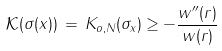<formula> <loc_0><loc_0><loc_500><loc_500>\mathcal { K } ( \sigma ( x ) ) \, = \, K _ { o , N } ( \sigma _ { x } ) \geq - \frac { w ^ { \prime \prime } ( r ) } { w ( r ) }</formula> 